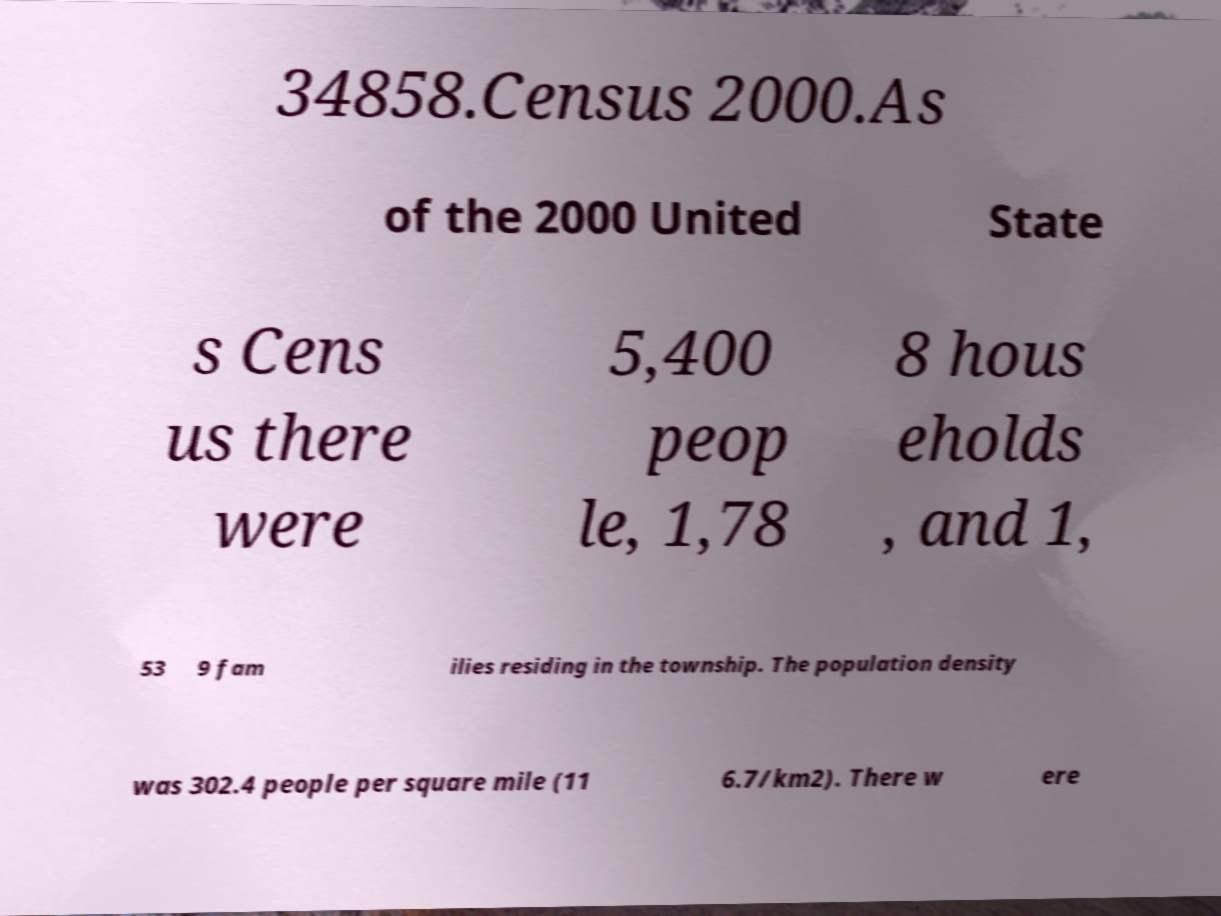I need the written content from this picture converted into text. Can you do that? 34858.Census 2000.As of the 2000 United State s Cens us there were 5,400 peop le, 1,78 8 hous eholds , and 1, 53 9 fam ilies residing in the township. The population density was 302.4 people per square mile (11 6.7/km2). There w ere 